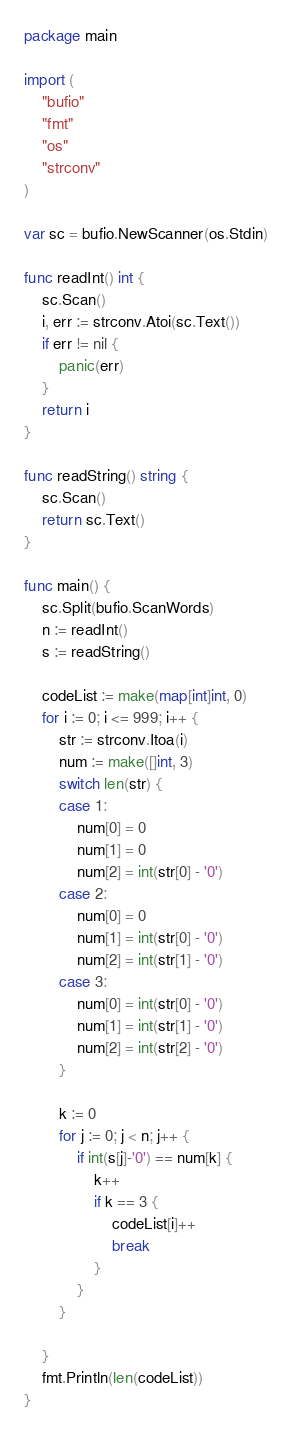Convert code to text. <code><loc_0><loc_0><loc_500><loc_500><_Go_>package main

import (
	"bufio"
	"fmt"
	"os"
	"strconv"
)

var sc = bufio.NewScanner(os.Stdin)

func readInt() int {
	sc.Scan()
	i, err := strconv.Atoi(sc.Text())
	if err != nil {
		panic(err)
	}
	return i
}

func readString() string {
	sc.Scan()
	return sc.Text()
}

func main() {
	sc.Split(bufio.ScanWords)
	n := readInt()
	s := readString()

	codeList := make(map[int]int, 0)
	for i := 0; i <= 999; i++ {
		str := strconv.Itoa(i)
		num := make([]int, 3)
		switch len(str) {
		case 1:
			num[0] = 0
			num[1] = 0
			num[2] = int(str[0] - '0')
		case 2:
			num[0] = 0
			num[1] = int(str[0] - '0')
			num[2] = int(str[1] - '0')
		case 3:
			num[0] = int(str[0] - '0')
			num[1] = int(str[1] - '0')
			num[2] = int(str[2] - '0')
		}

		k := 0
		for j := 0; j < n; j++ {
			if int(s[j]-'0') == num[k] {
				k++
				if k == 3 {
					codeList[i]++
					break
				}
			}
		}

	}
	fmt.Println(len(codeList))
}
</code> 